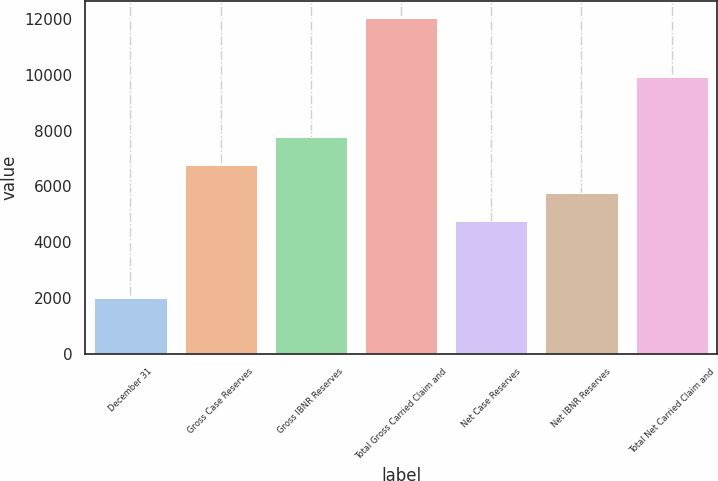Convert chart to OTSL. <chart><loc_0><loc_0><loc_500><loc_500><bar_chart><fcel>December 31<fcel>Gross Case Reserves<fcel>Gross IBNR Reserves<fcel>Total Gross Carried Claim and<fcel>Net Case Reserves<fcel>Net IBNR Reserves<fcel>Total Net Carried Claim and<nl><fcel>2007<fcel>6758.2<fcel>7762.3<fcel>12048<fcel>4750<fcel>5754.1<fcel>9920<nl></chart> 